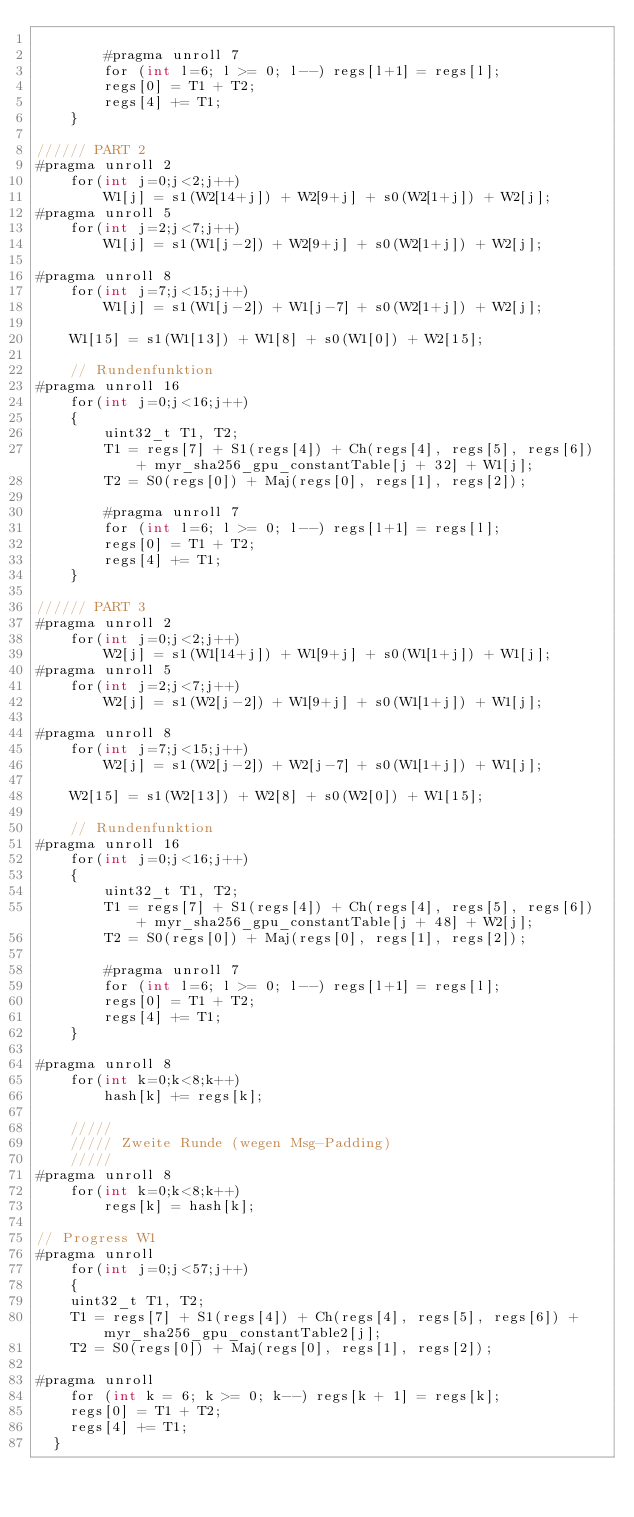Convert code to text. <code><loc_0><loc_0><loc_500><loc_500><_Cuda_>        
        #pragma unroll 7
        for (int l=6; l >= 0; l--) regs[l+1] = regs[l];
        regs[0] = T1 + T2;
        regs[4] += T1;
    }

////// PART 2
#pragma unroll 2
    for(int j=0;j<2;j++)
        W1[j] = s1(W2[14+j]) + W2[9+j] + s0(W2[1+j]) + W2[j];
#pragma unroll 5
    for(int j=2;j<7;j++)
        W1[j] = s1(W1[j-2]) + W2[9+j] + s0(W2[1+j]) + W2[j];

#pragma unroll 8
    for(int j=7;j<15;j++)
        W1[j] = s1(W1[j-2]) + W1[j-7] + s0(W2[1+j]) + W2[j];

    W1[15] = s1(W1[13]) + W1[8] + s0(W1[0]) + W2[15];

    // Rundenfunktion
#pragma unroll 16
    for(int j=0;j<16;j++)
    {
        uint32_t T1, T2;
        T1 = regs[7] + S1(regs[4]) + Ch(regs[4], regs[5], regs[6]) + myr_sha256_gpu_constantTable[j + 32] + W1[j];
        T2 = S0(regs[0]) + Maj(regs[0], regs[1], regs[2]);
        
        #pragma unroll 7
        for (int l=6; l >= 0; l--) regs[l+1] = regs[l];
        regs[0] = T1 + T2;
        regs[4] += T1;
    }

////// PART 3
#pragma unroll 2
    for(int j=0;j<2;j++)
        W2[j] = s1(W1[14+j]) + W1[9+j] + s0(W1[1+j]) + W1[j];
#pragma unroll 5
    for(int j=2;j<7;j++)
        W2[j] = s1(W2[j-2]) + W1[9+j] + s0(W1[1+j]) + W1[j];

#pragma unroll 8
    for(int j=7;j<15;j++)
        W2[j] = s1(W2[j-2]) + W2[j-7] + s0(W1[1+j]) + W1[j];

    W2[15] = s1(W2[13]) + W2[8] + s0(W2[0]) + W1[15];

    // Rundenfunktion
#pragma unroll 16
    for(int j=0;j<16;j++)
    {
        uint32_t T1, T2;
        T1 = regs[7] + S1(regs[4]) + Ch(regs[4], regs[5], regs[6]) + myr_sha256_gpu_constantTable[j + 48] + W2[j];
        T2 = S0(regs[0]) + Maj(regs[0], regs[1], regs[2]);
        
        #pragma unroll 7
        for (int l=6; l >= 0; l--) regs[l+1] = regs[l];
        regs[0] = T1 + T2;
        regs[4] += T1;
    }

#pragma unroll 8
    for(int k=0;k<8;k++)
        hash[k] += regs[k];

    /////
    ///// Zweite Runde (wegen Msg-Padding)
    /////
#pragma unroll 8
    for(int k=0;k<8;k++)
        regs[k] = hash[k];

// Progress W1
#pragma unroll 
    for(int j=0;j<57;j++)
    {
		uint32_t T1, T2;
		T1 = regs[7] + S1(regs[4]) + Ch(regs[4], regs[5], regs[6]) + myr_sha256_gpu_constantTable2[j];
		T2 = S0(regs[0]) + Maj(regs[0], regs[1], regs[2]);

#pragma unroll
		for (int k = 6; k >= 0; k--) regs[k + 1] = regs[k];
		regs[0] = T1 + T2;
		regs[4] += T1;
	}
</code> 